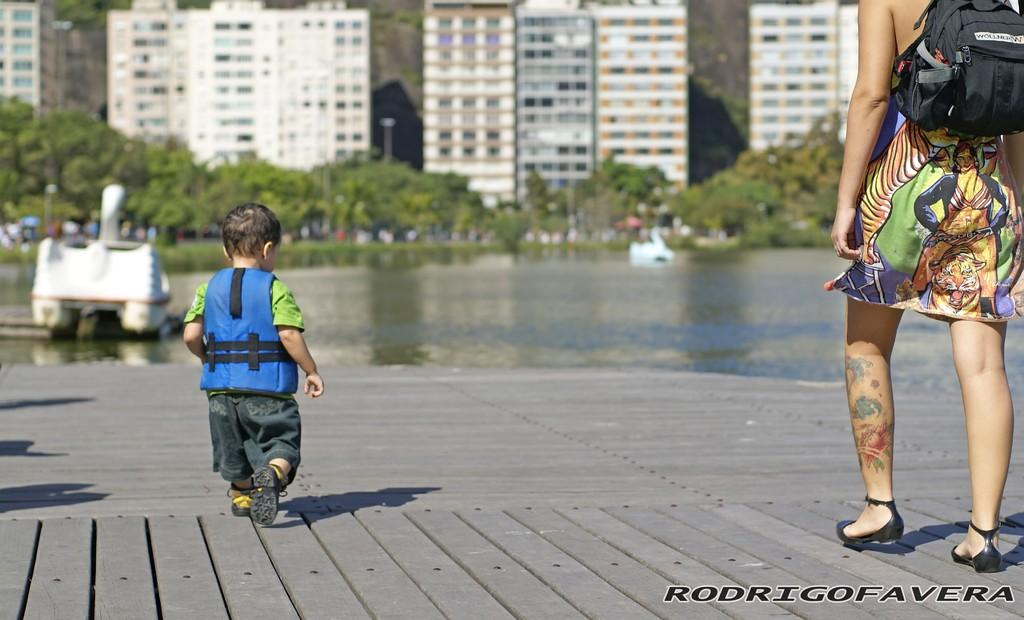What is the main subject of the picture? The main subject of the picture is a boy. What is the boy doing in the image? The boy is walking in the image. Who else is present in the picture? There is a woman in the picture. What is the woman wearing? The woman is wearing a bag. What can be seen in the background of the image? There is water, plants, and a building visible in the background of the image. What type of poison is the boy using to guide the woman in the image? There is no poison or guiding activity present in the image. The boy is simply walking, and the woman is wearing a bag. 